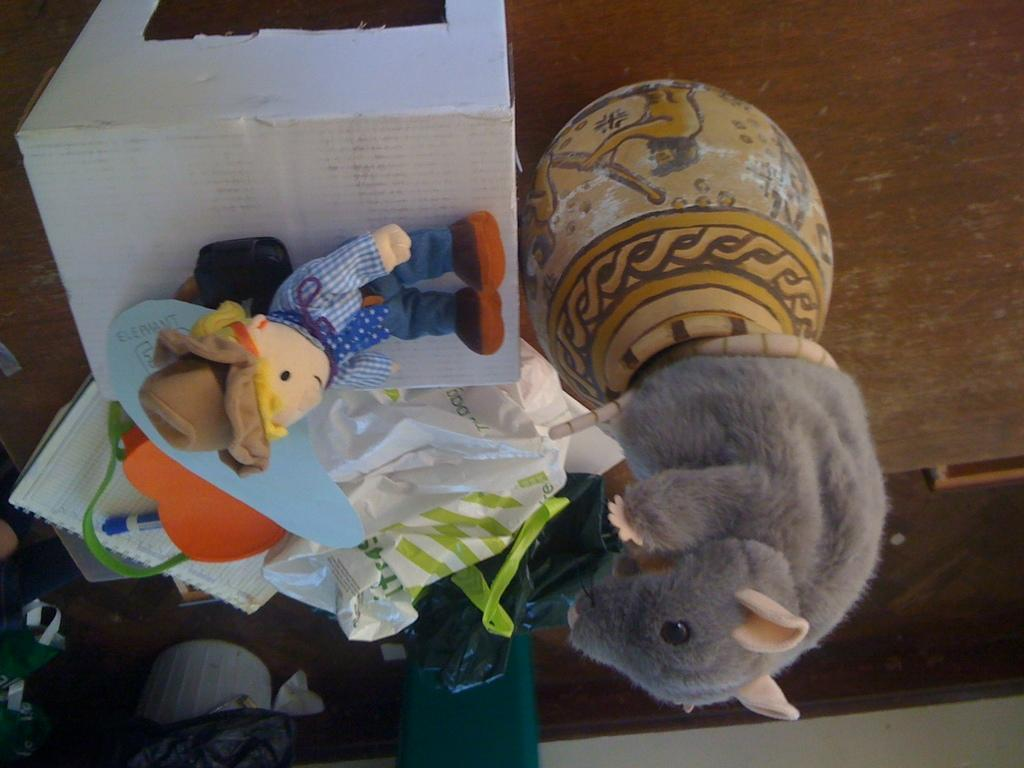What is on the table in the image? There is a pot, a cotton box, toys, a paper, a book, a bag, and a pen on the table in the image. What is the purpose of the plastic cover on the table? The purpose of the plastic cover is not specified in the image, but it could be used for protection or organization. Where is the dustbin located in the image? The dustbin is in the bottom left corner of the image. What is the black cover in the bottom left corner of the image? The black cover is in the bottom left corner of the image, but its purpose or function is not specified. What type of lawyer is depicted in the image? There is no lawyer present in the image; it features a table with various objects on it. Can you see an airplane flying in the background of the image? There is no airplane visible in the image; it focuses on objects on a table. Is there a scarecrow standing in the corner of the room in the image? There is no scarecrow present in the image; it features a table with various objects on it and a dustbin and black cover in the bottom left corner. 